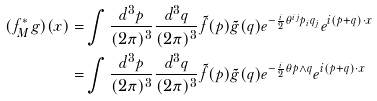<formula> <loc_0><loc_0><loc_500><loc_500>( f ^ { * } _ { M } g ) ( x ) = & \int \frac { d ^ { 3 } p } { ( 2 \pi ) ^ { 3 } } \frac { d ^ { 3 } q } { ( 2 \pi ) ^ { 3 } } \tilde { f } ( p ) \tilde { g } ( q ) e ^ { - \frac { i } { 2 } \theta ^ { i j } p _ { i } q _ { j } } e ^ { i ( p + q ) \cdot x } \\ = & \int \frac { d ^ { 3 } p } { ( 2 \pi ) ^ { 3 } } \frac { d ^ { 3 } q } { ( 2 \pi ) ^ { 3 } } \tilde { f } ( p ) \tilde { g } ( q ) e ^ { - \frac { i } { 2 } \theta p \wedge q } e ^ { i ( p + q ) \cdot x }</formula> 